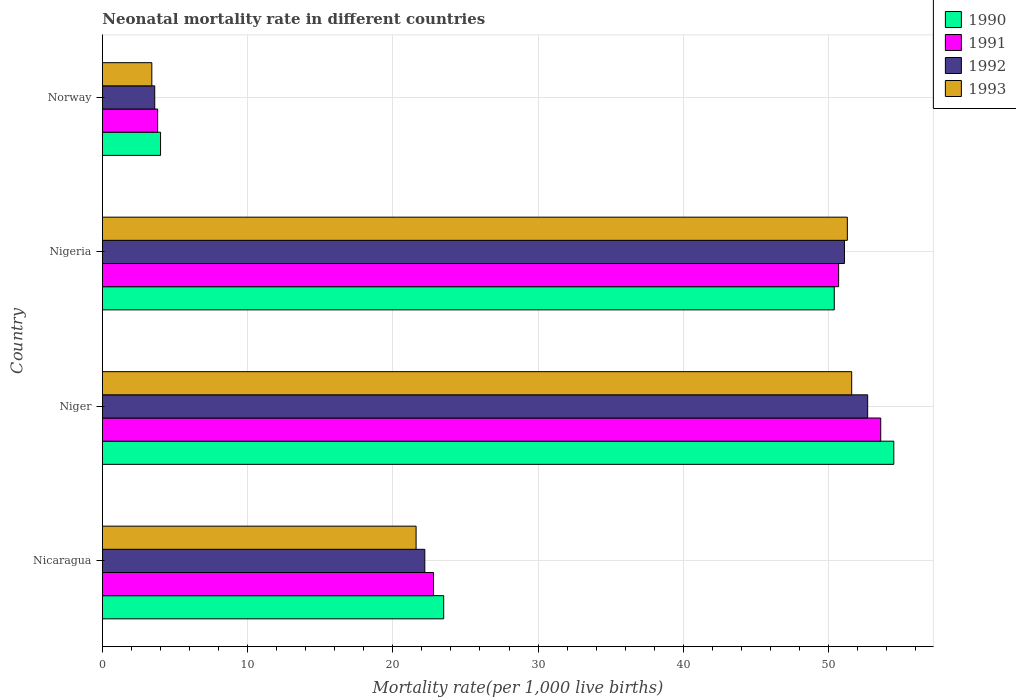How many groups of bars are there?
Your answer should be compact. 4. How many bars are there on the 2nd tick from the top?
Your answer should be very brief. 4. How many bars are there on the 2nd tick from the bottom?
Your answer should be compact. 4. What is the label of the 2nd group of bars from the top?
Your answer should be very brief. Nigeria. In how many cases, is the number of bars for a given country not equal to the number of legend labels?
Give a very brief answer. 0. What is the neonatal mortality rate in 1993 in Nicaragua?
Ensure brevity in your answer.  21.6. Across all countries, what is the maximum neonatal mortality rate in 1991?
Make the answer very short. 53.6. In which country was the neonatal mortality rate in 1991 maximum?
Ensure brevity in your answer.  Niger. In which country was the neonatal mortality rate in 1992 minimum?
Provide a short and direct response. Norway. What is the total neonatal mortality rate in 1993 in the graph?
Keep it short and to the point. 127.9. What is the difference between the neonatal mortality rate in 1992 in Nigeria and that in Norway?
Make the answer very short. 47.5. What is the difference between the neonatal mortality rate in 1992 in Niger and the neonatal mortality rate in 1990 in Norway?
Provide a short and direct response. 48.7. What is the average neonatal mortality rate in 1993 per country?
Provide a short and direct response. 31.98. What is the difference between the neonatal mortality rate in 1992 and neonatal mortality rate in 1991 in Nigeria?
Your response must be concise. 0.4. What is the ratio of the neonatal mortality rate in 1991 in Nicaragua to that in Niger?
Make the answer very short. 0.43. What is the difference between the highest and the second highest neonatal mortality rate in 1992?
Make the answer very short. 1.6. What is the difference between the highest and the lowest neonatal mortality rate in 1993?
Ensure brevity in your answer.  48.2. In how many countries, is the neonatal mortality rate in 1993 greater than the average neonatal mortality rate in 1993 taken over all countries?
Provide a succinct answer. 2. What does the 2nd bar from the top in Niger represents?
Your response must be concise. 1992. What does the 2nd bar from the bottom in Nigeria represents?
Your answer should be compact. 1991. Is it the case that in every country, the sum of the neonatal mortality rate in 1991 and neonatal mortality rate in 1993 is greater than the neonatal mortality rate in 1990?
Your answer should be very brief. Yes. Are all the bars in the graph horizontal?
Your response must be concise. Yes. Are the values on the major ticks of X-axis written in scientific E-notation?
Provide a succinct answer. No. How many legend labels are there?
Provide a succinct answer. 4. What is the title of the graph?
Make the answer very short. Neonatal mortality rate in different countries. Does "1986" appear as one of the legend labels in the graph?
Your answer should be compact. No. What is the label or title of the X-axis?
Offer a terse response. Mortality rate(per 1,0 live births). What is the Mortality rate(per 1,000 live births) of 1990 in Nicaragua?
Offer a very short reply. 23.5. What is the Mortality rate(per 1,000 live births) in 1991 in Nicaragua?
Ensure brevity in your answer.  22.8. What is the Mortality rate(per 1,000 live births) in 1992 in Nicaragua?
Ensure brevity in your answer.  22.2. What is the Mortality rate(per 1,000 live births) of 1993 in Nicaragua?
Give a very brief answer. 21.6. What is the Mortality rate(per 1,000 live births) of 1990 in Niger?
Give a very brief answer. 54.5. What is the Mortality rate(per 1,000 live births) in 1991 in Niger?
Your answer should be compact. 53.6. What is the Mortality rate(per 1,000 live births) in 1992 in Niger?
Your response must be concise. 52.7. What is the Mortality rate(per 1,000 live births) in 1993 in Niger?
Offer a terse response. 51.6. What is the Mortality rate(per 1,000 live births) in 1990 in Nigeria?
Ensure brevity in your answer.  50.4. What is the Mortality rate(per 1,000 live births) in 1991 in Nigeria?
Your response must be concise. 50.7. What is the Mortality rate(per 1,000 live births) of 1992 in Nigeria?
Make the answer very short. 51.1. What is the Mortality rate(per 1,000 live births) of 1993 in Nigeria?
Keep it short and to the point. 51.3. What is the Mortality rate(per 1,000 live births) in 1991 in Norway?
Ensure brevity in your answer.  3.8. Across all countries, what is the maximum Mortality rate(per 1,000 live births) of 1990?
Provide a succinct answer. 54.5. Across all countries, what is the maximum Mortality rate(per 1,000 live births) of 1991?
Offer a terse response. 53.6. Across all countries, what is the maximum Mortality rate(per 1,000 live births) in 1992?
Provide a short and direct response. 52.7. Across all countries, what is the maximum Mortality rate(per 1,000 live births) of 1993?
Offer a very short reply. 51.6. Across all countries, what is the minimum Mortality rate(per 1,000 live births) of 1991?
Give a very brief answer. 3.8. Across all countries, what is the minimum Mortality rate(per 1,000 live births) of 1992?
Provide a succinct answer. 3.6. Across all countries, what is the minimum Mortality rate(per 1,000 live births) of 1993?
Provide a succinct answer. 3.4. What is the total Mortality rate(per 1,000 live births) of 1990 in the graph?
Keep it short and to the point. 132.4. What is the total Mortality rate(per 1,000 live births) in 1991 in the graph?
Offer a terse response. 130.9. What is the total Mortality rate(per 1,000 live births) in 1992 in the graph?
Provide a succinct answer. 129.6. What is the total Mortality rate(per 1,000 live births) of 1993 in the graph?
Offer a terse response. 127.9. What is the difference between the Mortality rate(per 1,000 live births) of 1990 in Nicaragua and that in Niger?
Keep it short and to the point. -31. What is the difference between the Mortality rate(per 1,000 live births) of 1991 in Nicaragua and that in Niger?
Offer a terse response. -30.8. What is the difference between the Mortality rate(per 1,000 live births) in 1992 in Nicaragua and that in Niger?
Keep it short and to the point. -30.5. What is the difference between the Mortality rate(per 1,000 live births) of 1993 in Nicaragua and that in Niger?
Provide a succinct answer. -30. What is the difference between the Mortality rate(per 1,000 live births) of 1990 in Nicaragua and that in Nigeria?
Your answer should be very brief. -26.9. What is the difference between the Mortality rate(per 1,000 live births) of 1991 in Nicaragua and that in Nigeria?
Provide a succinct answer. -27.9. What is the difference between the Mortality rate(per 1,000 live births) of 1992 in Nicaragua and that in Nigeria?
Offer a very short reply. -28.9. What is the difference between the Mortality rate(per 1,000 live births) in 1993 in Nicaragua and that in Nigeria?
Your response must be concise. -29.7. What is the difference between the Mortality rate(per 1,000 live births) of 1990 in Nicaragua and that in Norway?
Provide a short and direct response. 19.5. What is the difference between the Mortality rate(per 1,000 live births) of 1992 in Nicaragua and that in Norway?
Ensure brevity in your answer.  18.6. What is the difference between the Mortality rate(per 1,000 live births) in 1990 in Niger and that in Nigeria?
Your answer should be very brief. 4.1. What is the difference between the Mortality rate(per 1,000 live births) of 1991 in Niger and that in Nigeria?
Offer a very short reply. 2.9. What is the difference between the Mortality rate(per 1,000 live births) in 1990 in Niger and that in Norway?
Make the answer very short. 50.5. What is the difference between the Mortality rate(per 1,000 live births) of 1991 in Niger and that in Norway?
Provide a short and direct response. 49.8. What is the difference between the Mortality rate(per 1,000 live births) in 1992 in Niger and that in Norway?
Provide a short and direct response. 49.1. What is the difference between the Mortality rate(per 1,000 live births) in 1993 in Niger and that in Norway?
Offer a terse response. 48.2. What is the difference between the Mortality rate(per 1,000 live births) of 1990 in Nigeria and that in Norway?
Your response must be concise. 46.4. What is the difference between the Mortality rate(per 1,000 live births) of 1991 in Nigeria and that in Norway?
Offer a terse response. 46.9. What is the difference between the Mortality rate(per 1,000 live births) in 1992 in Nigeria and that in Norway?
Your answer should be very brief. 47.5. What is the difference between the Mortality rate(per 1,000 live births) in 1993 in Nigeria and that in Norway?
Your response must be concise. 47.9. What is the difference between the Mortality rate(per 1,000 live births) of 1990 in Nicaragua and the Mortality rate(per 1,000 live births) of 1991 in Niger?
Make the answer very short. -30.1. What is the difference between the Mortality rate(per 1,000 live births) in 1990 in Nicaragua and the Mortality rate(per 1,000 live births) in 1992 in Niger?
Your answer should be compact. -29.2. What is the difference between the Mortality rate(per 1,000 live births) of 1990 in Nicaragua and the Mortality rate(per 1,000 live births) of 1993 in Niger?
Make the answer very short. -28.1. What is the difference between the Mortality rate(per 1,000 live births) of 1991 in Nicaragua and the Mortality rate(per 1,000 live births) of 1992 in Niger?
Ensure brevity in your answer.  -29.9. What is the difference between the Mortality rate(per 1,000 live births) in 1991 in Nicaragua and the Mortality rate(per 1,000 live births) in 1993 in Niger?
Offer a terse response. -28.8. What is the difference between the Mortality rate(per 1,000 live births) of 1992 in Nicaragua and the Mortality rate(per 1,000 live births) of 1993 in Niger?
Give a very brief answer. -29.4. What is the difference between the Mortality rate(per 1,000 live births) in 1990 in Nicaragua and the Mortality rate(per 1,000 live births) in 1991 in Nigeria?
Ensure brevity in your answer.  -27.2. What is the difference between the Mortality rate(per 1,000 live births) in 1990 in Nicaragua and the Mortality rate(per 1,000 live births) in 1992 in Nigeria?
Provide a succinct answer. -27.6. What is the difference between the Mortality rate(per 1,000 live births) in 1990 in Nicaragua and the Mortality rate(per 1,000 live births) in 1993 in Nigeria?
Ensure brevity in your answer.  -27.8. What is the difference between the Mortality rate(per 1,000 live births) of 1991 in Nicaragua and the Mortality rate(per 1,000 live births) of 1992 in Nigeria?
Your answer should be compact. -28.3. What is the difference between the Mortality rate(per 1,000 live births) of 1991 in Nicaragua and the Mortality rate(per 1,000 live births) of 1993 in Nigeria?
Offer a terse response. -28.5. What is the difference between the Mortality rate(per 1,000 live births) in 1992 in Nicaragua and the Mortality rate(per 1,000 live births) in 1993 in Nigeria?
Ensure brevity in your answer.  -29.1. What is the difference between the Mortality rate(per 1,000 live births) in 1990 in Nicaragua and the Mortality rate(per 1,000 live births) in 1993 in Norway?
Ensure brevity in your answer.  20.1. What is the difference between the Mortality rate(per 1,000 live births) in 1991 in Nicaragua and the Mortality rate(per 1,000 live births) in 1992 in Norway?
Offer a very short reply. 19.2. What is the difference between the Mortality rate(per 1,000 live births) of 1991 in Nicaragua and the Mortality rate(per 1,000 live births) of 1993 in Norway?
Ensure brevity in your answer.  19.4. What is the difference between the Mortality rate(per 1,000 live births) in 1990 in Niger and the Mortality rate(per 1,000 live births) in 1991 in Nigeria?
Provide a short and direct response. 3.8. What is the difference between the Mortality rate(per 1,000 live births) in 1990 in Niger and the Mortality rate(per 1,000 live births) in 1993 in Nigeria?
Give a very brief answer. 3.2. What is the difference between the Mortality rate(per 1,000 live births) of 1992 in Niger and the Mortality rate(per 1,000 live births) of 1993 in Nigeria?
Provide a succinct answer. 1.4. What is the difference between the Mortality rate(per 1,000 live births) in 1990 in Niger and the Mortality rate(per 1,000 live births) in 1991 in Norway?
Make the answer very short. 50.7. What is the difference between the Mortality rate(per 1,000 live births) in 1990 in Niger and the Mortality rate(per 1,000 live births) in 1992 in Norway?
Your response must be concise. 50.9. What is the difference between the Mortality rate(per 1,000 live births) in 1990 in Niger and the Mortality rate(per 1,000 live births) in 1993 in Norway?
Your response must be concise. 51.1. What is the difference between the Mortality rate(per 1,000 live births) of 1991 in Niger and the Mortality rate(per 1,000 live births) of 1993 in Norway?
Ensure brevity in your answer.  50.2. What is the difference between the Mortality rate(per 1,000 live births) in 1992 in Niger and the Mortality rate(per 1,000 live births) in 1993 in Norway?
Provide a short and direct response. 49.3. What is the difference between the Mortality rate(per 1,000 live births) in 1990 in Nigeria and the Mortality rate(per 1,000 live births) in 1991 in Norway?
Keep it short and to the point. 46.6. What is the difference between the Mortality rate(per 1,000 live births) of 1990 in Nigeria and the Mortality rate(per 1,000 live births) of 1992 in Norway?
Provide a short and direct response. 46.8. What is the difference between the Mortality rate(per 1,000 live births) in 1991 in Nigeria and the Mortality rate(per 1,000 live births) in 1992 in Norway?
Your answer should be compact. 47.1. What is the difference between the Mortality rate(per 1,000 live births) of 1991 in Nigeria and the Mortality rate(per 1,000 live births) of 1993 in Norway?
Keep it short and to the point. 47.3. What is the difference between the Mortality rate(per 1,000 live births) in 1992 in Nigeria and the Mortality rate(per 1,000 live births) in 1993 in Norway?
Give a very brief answer. 47.7. What is the average Mortality rate(per 1,000 live births) of 1990 per country?
Provide a succinct answer. 33.1. What is the average Mortality rate(per 1,000 live births) of 1991 per country?
Your answer should be very brief. 32.73. What is the average Mortality rate(per 1,000 live births) of 1992 per country?
Give a very brief answer. 32.4. What is the average Mortality rate(per 1,000 live births) of 1993 per country?
Give a very brief answer. 31.98. What is the difference between the Mortality rate(per 1,000 live births) of 1990 and Mortality rate(per 1,000 live births) of 1992 in Nicaragua?
Give a very brief answer. 1.3. What is the difference between the Mortality rate(per 1,000 live births) in 1990 and Mortality rate(per 1,000 live births) in 1993 in Nicaragua?
Offer a terse response. 1.9. What is the difference between the Mortality rate(per 1,000 live births) in 1991 and Mortality rate(per 1,000 live births) in 1993 in Nicaragua?
Ensure brevity in your answer.  1.2. What is the difference between the Mortality rate(per 1,000 live births) in 1990 and Mortality rate(per 1,000 live births) in 1992 in Niger?
Provide a short and direct response. 1.8. What is the difference between the Mortality rate(per 1,000 live births) of 1990 and Mortality rate(per 1,000 live births) of 1993 in Niger?
Your response must be concise. 2.9. What is the difference between the Mortality rate(per 1,000 live births) in 1991 and Mortality rate(per 1,000 live births) in 1993 in Niger?
Keep it short and to the point. 2. What is the difference between the Mortality rate(per 1,000 live births) in 1992 and Mortality rate(per 1,000 live births) in 1993 in Niger?
Provide a short and direct response. 1.1. What is the difference between the Mortality rate(per 1,000 live births) in 1990 and Mortality rate(per 1,000 live births) in 1992 in Nigeria?
Your response must be concise. -0.7. What is the difference between the Mortality rate(per 1,000 live births) of 1991 and Mortality rate(per 1,000 live births) of 1992 in Nigeria?
Provide a succinct answer. -0.4. What is the difference between the Mortality rate(per 1,000 live births) of 1991 and Mortality rate(per 1,000 live births) of 1993 in Nigeria?
Provide a succinct answer. -0.6. What is the difference between the Mortality rate(per 1,000 live births) of 1992 and Mortality rate(per 1,000 live births) of 1993 in Nigeria?
Make the answer very short. -0.2. What is the difference between the Mortality rate(per 1,000 live births) in 1991 and Mortality rate(per 1,000 live births) in 1993 in Norway?
Your answer should be compact. 0.4. What is the ratio of the Mortality rate(per 1,000 live births) of 1990 in Nicaragua to that in Niger?
Provide a short and direct response. 0.43. What is the ratio of the Mortality rate(per 1,000 live births) in 1991 in Nicaragua to that in Niger?
Your answer should be compact. 0.43. What is the ratio of the Mortality rate(per 1,000 live births) in 1992 in Nicaragua to that in Niger?
Make the answer very short. 0.42. What is the ratio of the Mortality rate(per 1,000 live births) of 1993 in Nicaragua to that in Niger?
Give a very brief answer. 0.42. What is the ratio of the Mortality rate(per 1,000 live births) of 1990 in Nicaragua to that in Nigeria?
Offer a very short reply. 0.47. What is the ratio of the Mortality rate(per 1,000 live births) of 1991 in Nicaragua to that in Nigeria?
Your answer should be very brief. 0.45. What is the ratio of the Mortality rate(per 1,000 live births) of 1992 in Nicaragua to that in Nigeria?
Give a very brief answer. 0.43. What is the ratio of the Mortality rate(per 1,000 live births) of 1993 in Nicaragua to that in Nigeria?
Your answer should be compact. 0.42. What is the ratio of the Mortality rate(per 1,000 live births) in 1990 in Nicaragua to that in Norway?
Offer a very short reply. 5.88. What is the ratio of the Mortality rate(per 1,000 live births) in 1992 in Nicaragua to that in Norway?
Ensure brevity in your answer.  6.17. What is the ratio of the Mortality rate(per 1,000 live births) in 1993 in Nicaragua to that in Norway?
Ensure brevity in your answer.  6.35. What is the ratio of the Mortality rate(per 1,000 live births) in 1990 in Niger to that in Nigeria?
Your response must be concise. 1.08. What is the ratio of the Mortality rate(per 1,000 live births) of 1991 in Niger to that in Nigeria?
Keep it short and to the point. 1.06. What is the ratio of the Mortality rate(per 1,000 live births) of 1992 in Niger to that in Nigeria?
Your response must be concise. 1.03. What is the ratio of the Mortality rate(per 1,000 live births) of 1993 in Niger to that in Nigeria?
Your response must be concise. 1.01. What is the ratio of the Mortality rate(per 1,000 live births) of 1990 in Niger to that in Norway?
Provide a succinct answer. 13.62. What is the ratio of the Mortality rate(per 1,000 live births) in 1991 in Niger to that in Norway?
Offer a terse response. 14.11. What is the ratio of the Mortality rate(per 1,000 live births) of 1992 in Niger to that in Norway?
Keep it short and to the point. 14.64. What is the ratio of the Mortality rate(per 1,000 live births) in 1993 in Niger to that in Norway?
Keep it short and to the point. 15.18. What is the ratio of the Mortality rate(per 1,000 live births) in 1990 in Nigeria to that in Norway?
Keep it short and to the point. 12.6. What is the ratio of the Mortality rate(per 1,000 live births) in 1991 in Nigeria to that in Norway?
Provide a succinct answer. 13.34. What is the ratio of the Mortality rate(per 1,000 live births) of 1992 in Nigeria to that in Norway?
Give a very brief answer. 14.19. What is the ratio of the Mortality rate(per 1,000 live births) in 1993 in Nigeria to that in Norway?
Your response must be concise. 15.09. What is the difference between the highest and the second highest Mortality rate(per 1,000 live births) of 1991?
Your answer should be very brief. 2.9. What is the difference between the highest and the second highest Mortality rate(per 1,000 live births) of 1992?
Give a very brief answer. 1.6. What is the difference between the highest and the lowest Mortality rate(per 1,000 live births) of 1990?
Keep it short and to the point. 50.5. What is the difference between the highest and the lowest Mortality rate(per 1,000 live births) in 1991?
Provide a succinct answer. 49.8. What is the difference between the highest and the lowest Mortality rate(per 1,000 live births) of 1992?
Offer a very short reply. 49.1. What is the difference between the highest and the lowest Mortality rate(per 1,000 live births) in 1993?
Your answer should be very brief. 48.2. 